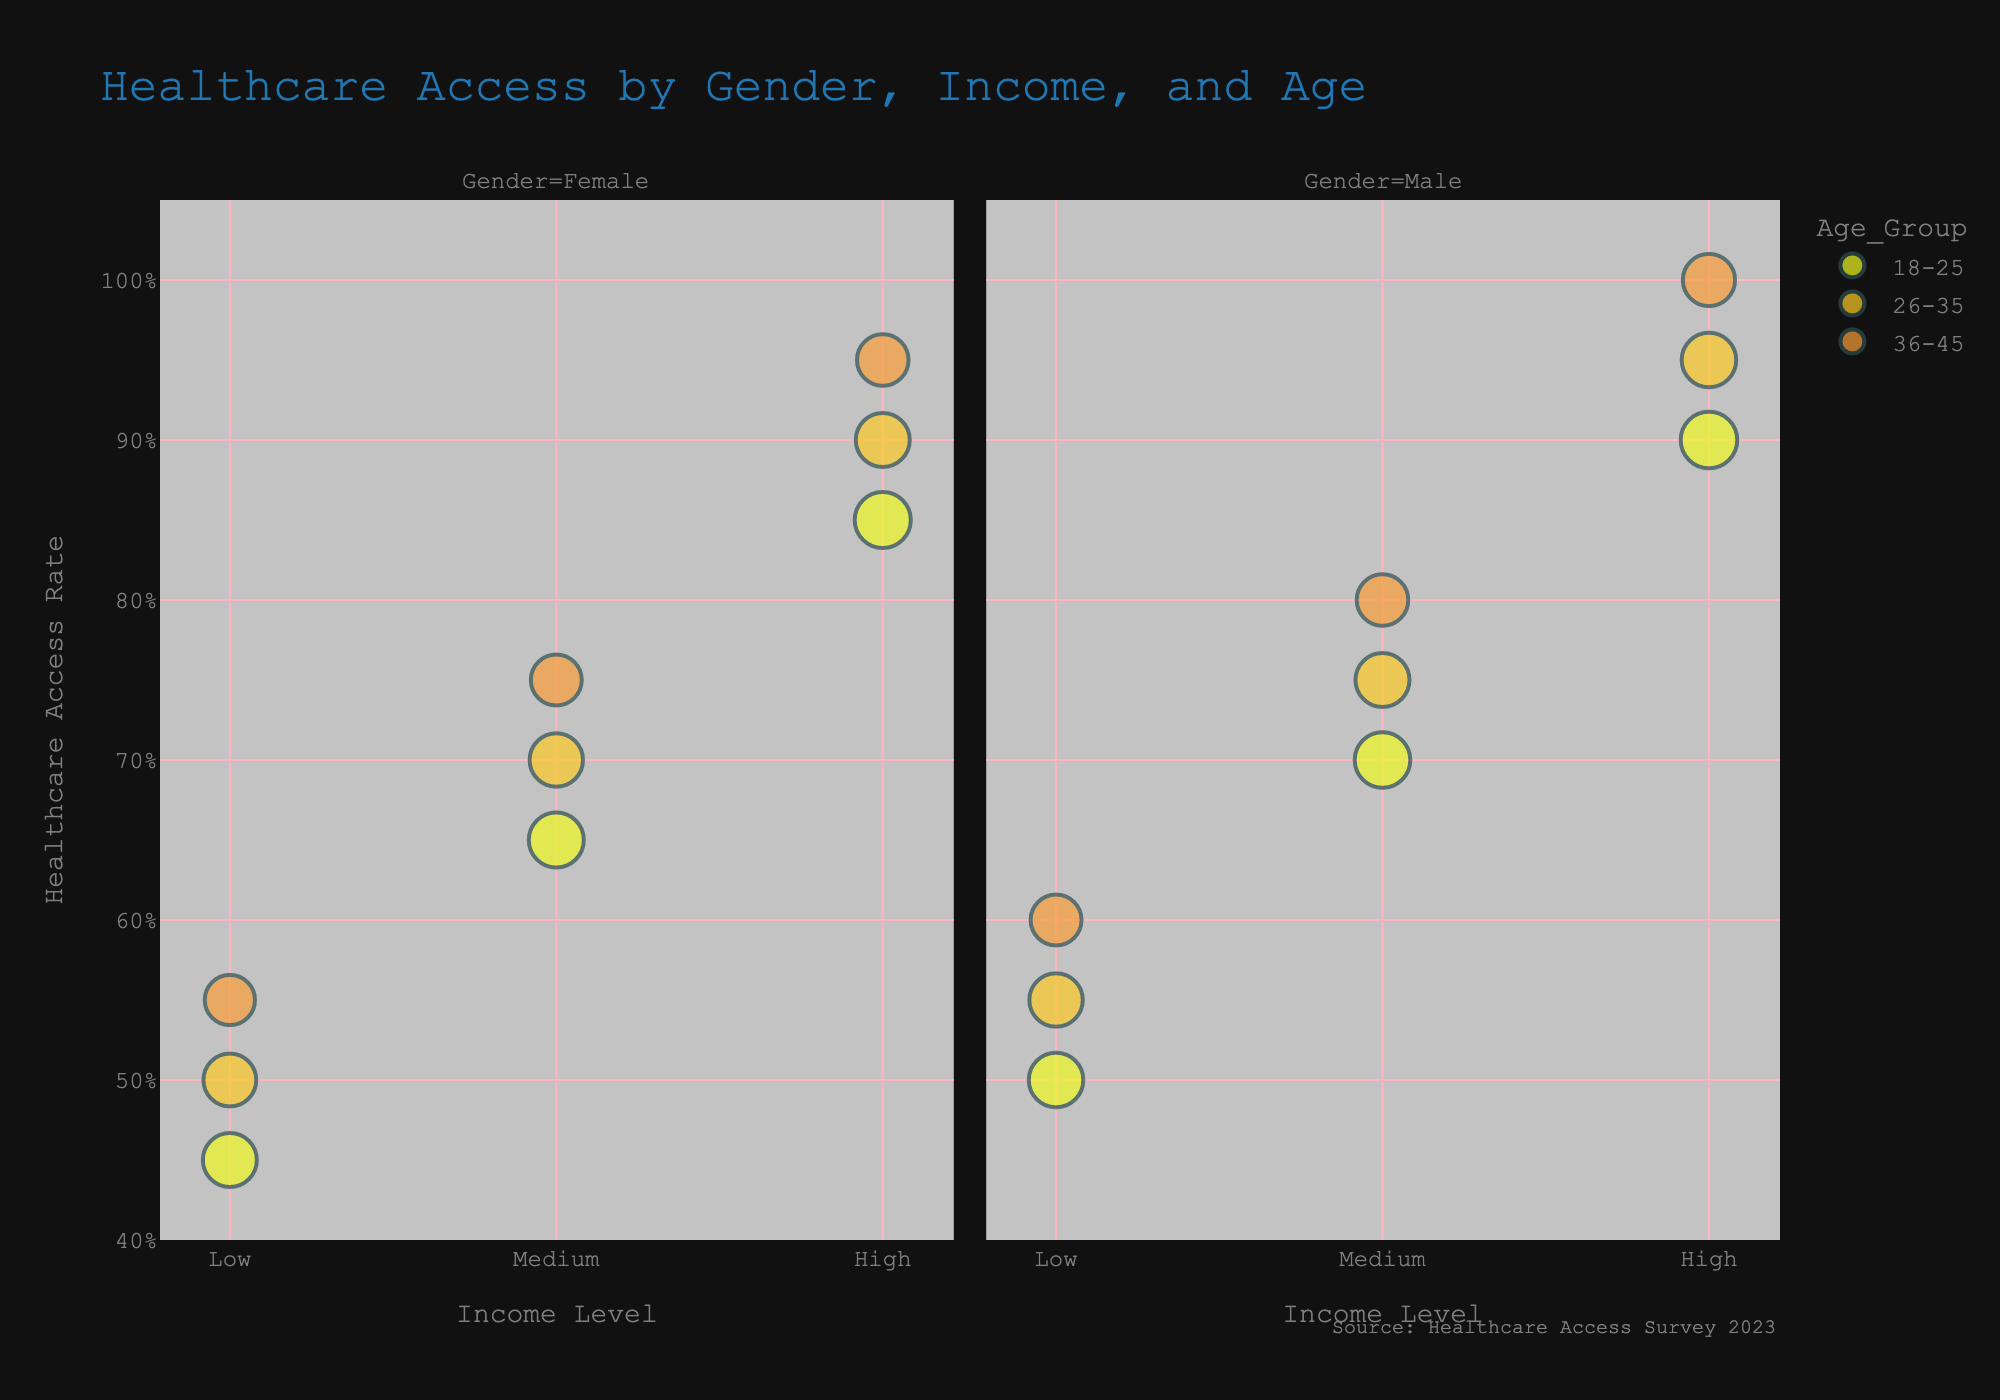How does the healthcare access rate compare for males and females in the high-income level for the 36-45 age group? For males in the high-income level, the access rate for the 36-45 age group is 100%, while for females in the same category, the access rate is 95%. A comparison of these access rates reveals that males have a slightly higher access rate.
Answer: Males: 100%, Females: 95% What is the general trend in healthcare access as income levels increase for females across all age groups? As income levels increase for females, the healthcare access rate generally increases across all age groups. Low-income levels have access rates between 45%-55%, medium-income levels have access rates between 65%-75%, and high-income levels have access rates between 85%-95%.
Answer: Increasing Among males aged 18-25, which income level has the highest healthcare access rate? For males aged 18-25, the high-income level has the highest healthcare access rate of 90%. Checking different income levels shows that low-income is at 50% and medium-income is at 70%.
Answer: High-income If we compare the population sizes, which age group among medium-income males has the largest bubble size? Among medium-income males, the 18-25 age group has the largest bubble, denoting the largest population size. This can be observed from the visual representation of bubble sizes.
Answer: 18-25 age group What is the population size of females aged 26-35 with medium income, and how does their access rate compare to males of the same group? The population size for females aged 26-35 with medium income is 1,150,000. Their access rate is 70%, while males of the same group have an access rate of 75%. A comparison shows that males have a slightly higher access rate.
Answer: Pop: 1,150,000, Males have higher How does the healthcare access rate for the high-income 18-25 age group compare to the low-income 18-25 age group within both genders? For the high-income 18-25 age group, the access rates are higher compared to the low-income 18-25 age group within both genders. High-income females have an 85% access rate vs. 45% for low-income; high-income males have a 90% access rate vs. 50% for low-income.
Answer: High-income group has higher In terms of healthcare access rate, which gender and age group combination has the highest rate overall? The highest healthcare access rate overall is for males in the 36-45 age group with a high-income level, which is 100%. This is visibly the topmost point on the y-axis within Gender = Male.
Answer: Males 36-45, High-income How does the healthcare access rate progress across age groups for males with a low-income level? For males with a low-income level, the healthcare access rate progresses from 50% in the 18-25 age group, to 55% in the 26-35 age group, and finally to 60% in the 36-45 age group, indicating an increasing trend.
Answer: Increasing What's the difference in healthcare access rate between high-income females aged 26-35 and medium-income males of the same age group? High-income females aged 26-35 have a healthcare access rate of 90%, whereas medium-income males of the same age group have a rate of 75%. The difference between these rates is 90% - 75% = 15%.
Answer: 15% 